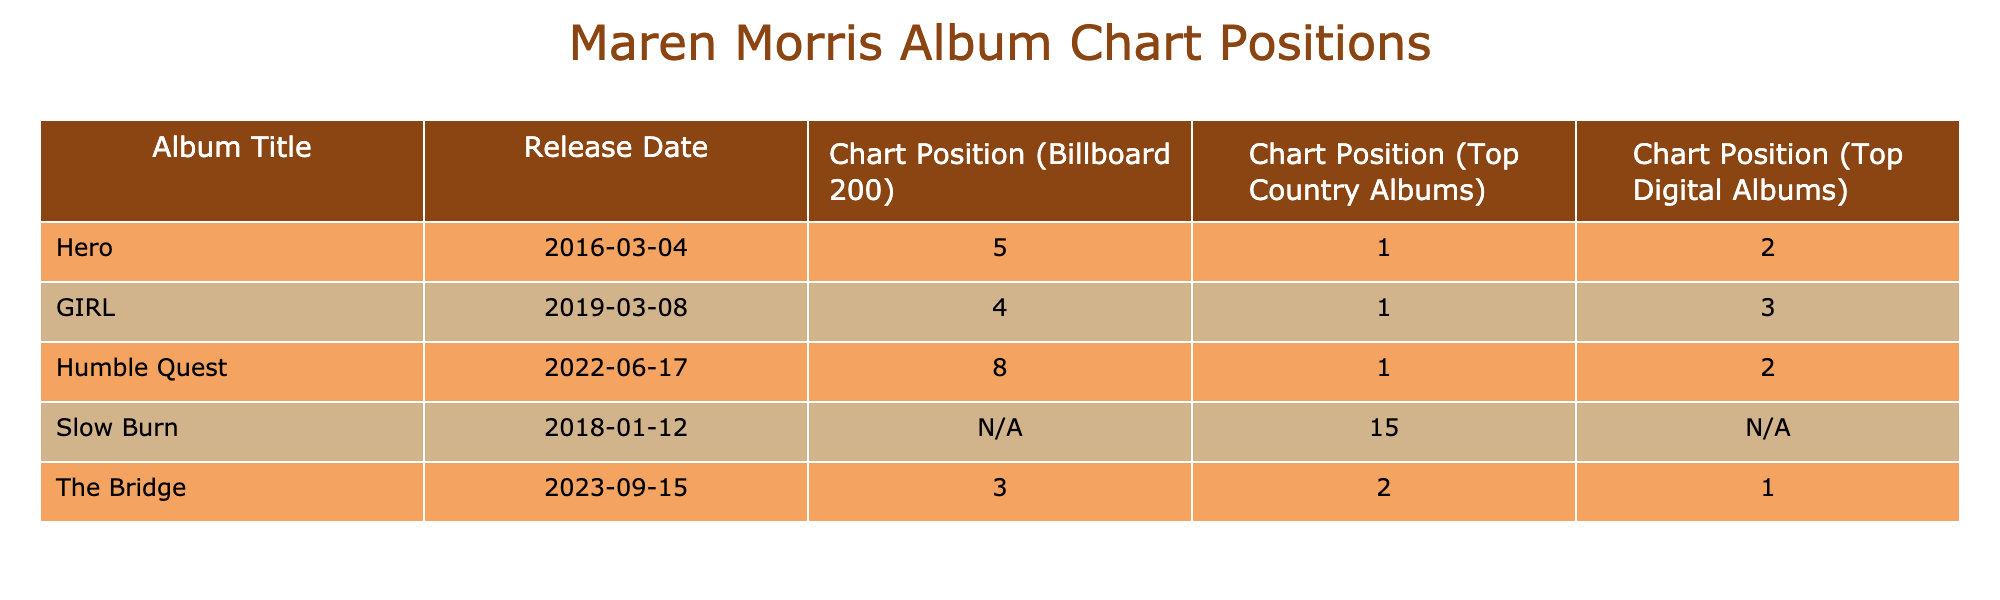What is the chart position of the album "GIRL" on the Billboard 200? The table lists the chart position for "GIRL" under the "Chart Position (Billboard 200)" column. It shows the value as 4.
Answer: 4 Which album has the highest chart position on the Top Country Albums chart? Looking at the "Chart Position (Top Country Albums)" column, all albums except "Slow Burn" show a position. The highest position is 1, which belongs to "Hero," "GIRL," and "Humble Quest."
Answer: Hero, GIRL, Humble Quest How many albums in the table reached the number one position on the Top Country Albums chart? Checking the "Chart Position (Top Country Albums)" column, "Hero," "GIRL," and "Humble Quest" all reached position 1. So there are three such albums.
Answer: 3 Is there an album that did not reach the Top 10 on the Billboard 200 chart? In the "Chart Position (Billboard 200)" column, both "Slow Burn" (missing value) and "Humble Quest" (position 8) meet this condition. Therefore, "Slow Burn" did not reach the Top 10.
Answer: Yes Which album released most recently and what is its Billboard 200 position? The most recent album in the table is "The Bridge," released on 2023-09-15. Its Billboard 200 position is listed as 3.
Answer: The Bridge, 3 What is the difference in chart position for the album "Humble Quest" between the Billboard 200 and Top Country Albums charts? "Humble Quest" is number 8 on the Billboard 200 and number 1 on the Top Country Albums chart. The difference is calculated by subtracting 1 from 8, resulting in a difference of 7 positions.
Answer: 7 Which album achieved the lowest chart position on the Top Digital Albums chart? The "Chart Position (Top Digital Albums)" for "Slow Burn" is not available (N/A), while others have positions. Therefore, since "Slow Burn" has no value, it is deemed the lowest.
Answer: Slow Burn How many albums released did not chart on the Top Digital Albums list? In the table, only "Slow Burn" is listed as not having a Top Digital Albums position (N/A), so this album should be counted.
Answer: 1 What is the average chart position on the Billboard 200 for the first three albums? The first three albums are "Hero," "GIRL," and "Humble Quest" with positions 5, 4, and 8, respectively. Summing these gives (5+4+8)=17, and dividing by 3 gives an average of 5.67.
Answer: 5.67 Is it true that "The Bridge" has the highest chart position on both the Billboard 200 and the Top Digital Albums? "The Bridge" is at position 3 on the Billboard 200 and position 1 on the Top Digital Albums, which is the highest for that chart. However, the highest position for the Billboard 200 is position 4 for "GIRL." Therefore, "The Bridge" is not the highest on both charts.
Answer: No 